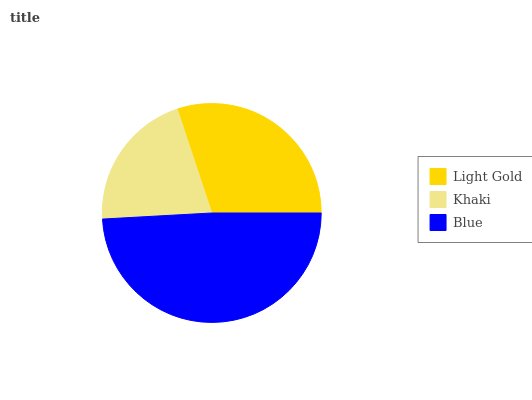Is Khaki the minimum?
Answer yes or no. Yes. Is Blue the maximum?
Answer yes or no. Yes. Is Blue the minimum?
Answer yes or no. No. Is Khaki the maximum?
Answer yes or no. No. Is Blue greater than Khaki?
Answer yes or no. Yes. Is Khaki less than Blue?
Answer yes or no. Yes. Is Khaki greater than Blue?
Answer yes or no. No. Is Blue less than Khaki?
Answer yes or no. No. Is Light Gold the high median?
Answer yes or no. Yes. Is Light Gold the low median?
Answer yes or no. Yes. Is Blue the high median?
Answer yes or no. No. Is Khaki the low median?
Answer yes or no. No. 